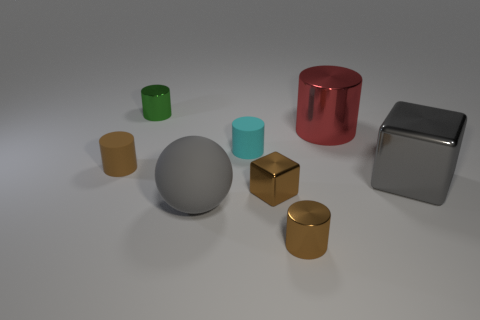Subtract 4 cylinders. How many cylinders are left? 1 Subtract all cyan cylinders. How many cylinders are left? 4 Subtract all small brown rubber cylinders. How many cylinders are left? 4 Add 1 cubes. How many objects exist? 9 Subtract 0 blue cylinders. How many objects are left? 8 Subtract all cylinders. How many objects are left? 3 Subtract all green balls. Subtract all cyan cylinders. How many balls are left? 1 Subtract all red spheres. How many gray blocks are left? 1 Subtract all big objects. Subtract all big gray cubes. How many objects are left? 4 Add 7 big red cylinders. How many big red cylinders are left? 8 